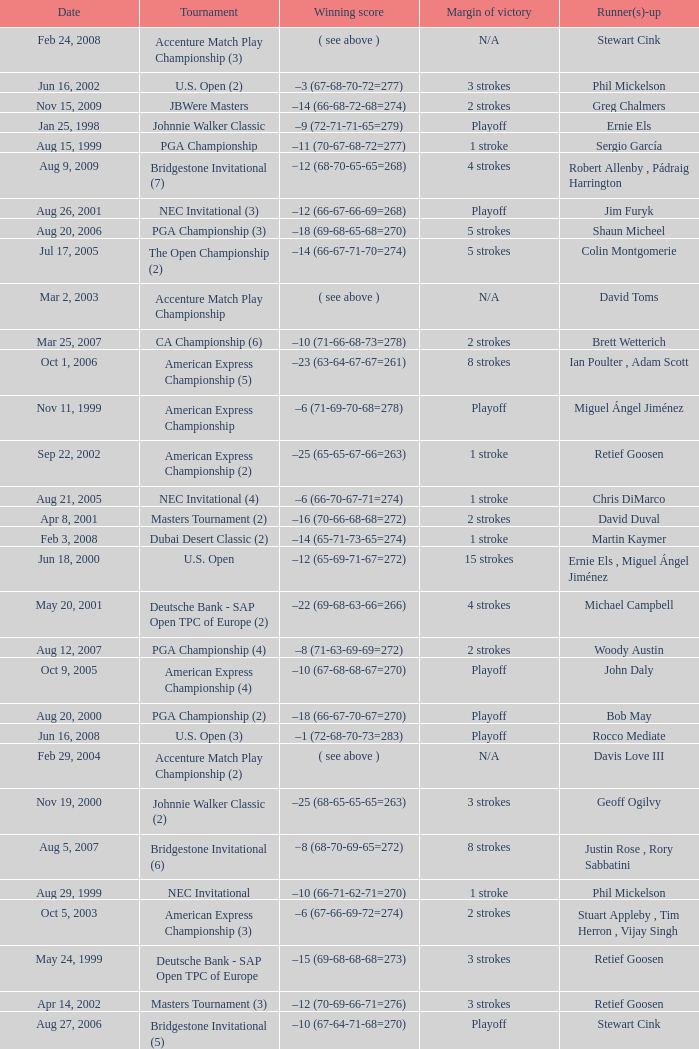Who is Runner(s)-up that has a Date of may 24, 1999? Retief Goosen. 